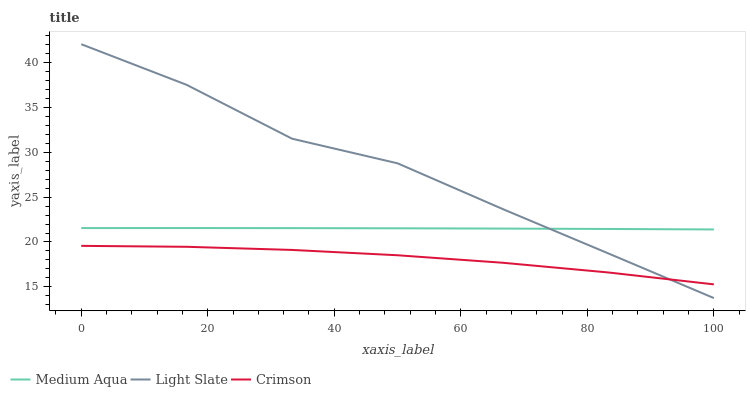Does Crimson have the minimum area under the curve?
Answer yes or no. Yes. Does Light Slate have the maximum area under the curve?
Answer yes or no. Yes. Does Medium Aqua have the minimum area under the curve?
Answer yes or no. No. Does Medium Aqua have the maximum area under the curve?
Answer yes or no. No. Is Medium Aqua the smoothest?
Answer yes or no. Yes. Is Light Slate the roughest?
Answer yes or no. Yes. Is Crimson the smoothest?
Answer yes or no. No. Is Crimson the roughest?
Answer yes or no. No. Does Light Slate have the lowest value?
Answer yes or no. Yes. Does Crimson have the lowest value?
Answer yes or no. No. Does Light Slate have the highest value?
Answer yes or no. Yes. Does Medium Aqua have the highest value?
Answer yes or no. No. Is Crimson less than Medium Aqua?
Answer yes or no. Yes. Is Medium Aqua greater than Crimson?
Answer yes or no. Yes. Does Crimson intersect Light Slate?
Answer yes or no. Yes. Is Crimson less than Light Slate?
Answer yes or no. No. Is Crimson greater than Light Slate?
Answer yes or no. No. Does Crimson intersect Medium Aqua?
Answer yes or no. No. 